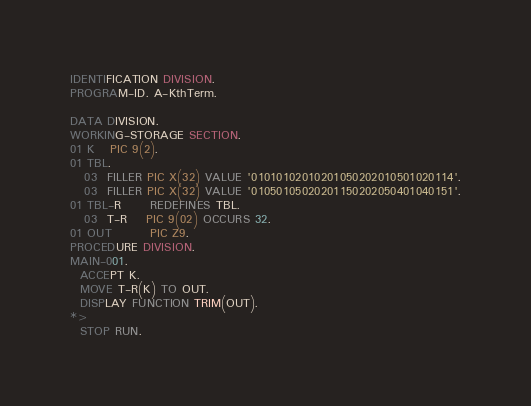<code> <loc_0><loc_0><loc_500><loc_500><_COBOL_>IDENTIFICATION DIVISION.
PROGRAM-ID. A-KthTerm.
 
DATA DIVISION.
WORKING-STORAGE SECTION.
01 K   PIC 9(2).
01 TBL.
   03  FILLER PIC X(32) VALUE '01010102010201050202010501020114'.
   03  FILLER PIC X(32) VALUE '01050105020201150202050401040151'.
01 TBL-R      REDEFINES TBL.
   03  T-R    PIC 9(02) OCCURS 32.
01 OUT        PIC Z9.
PROCEDURE DIVISION.
MAIN-001.
  ACCEPT K.
  MOVE T-R(K) TO OUT.
  DISPLAY FUNCTION TRIM(OUT).
*>
  STOP RUN.
</code> 